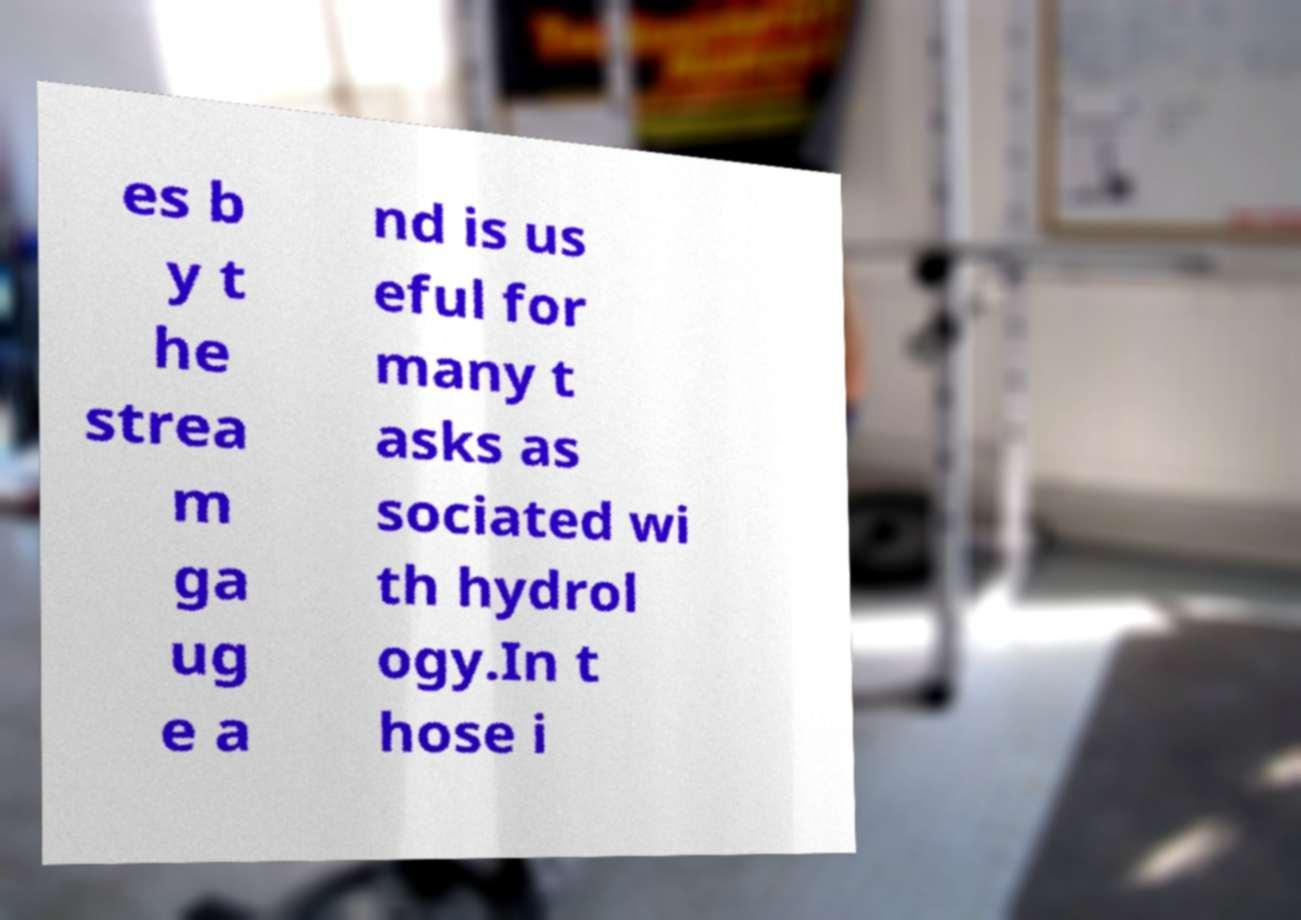Could you extract and type out the text from this image? es b y t he strea m ga ug e a nd is us eful for many t asks as sociated wi th hydrol ogy.In t hose i 